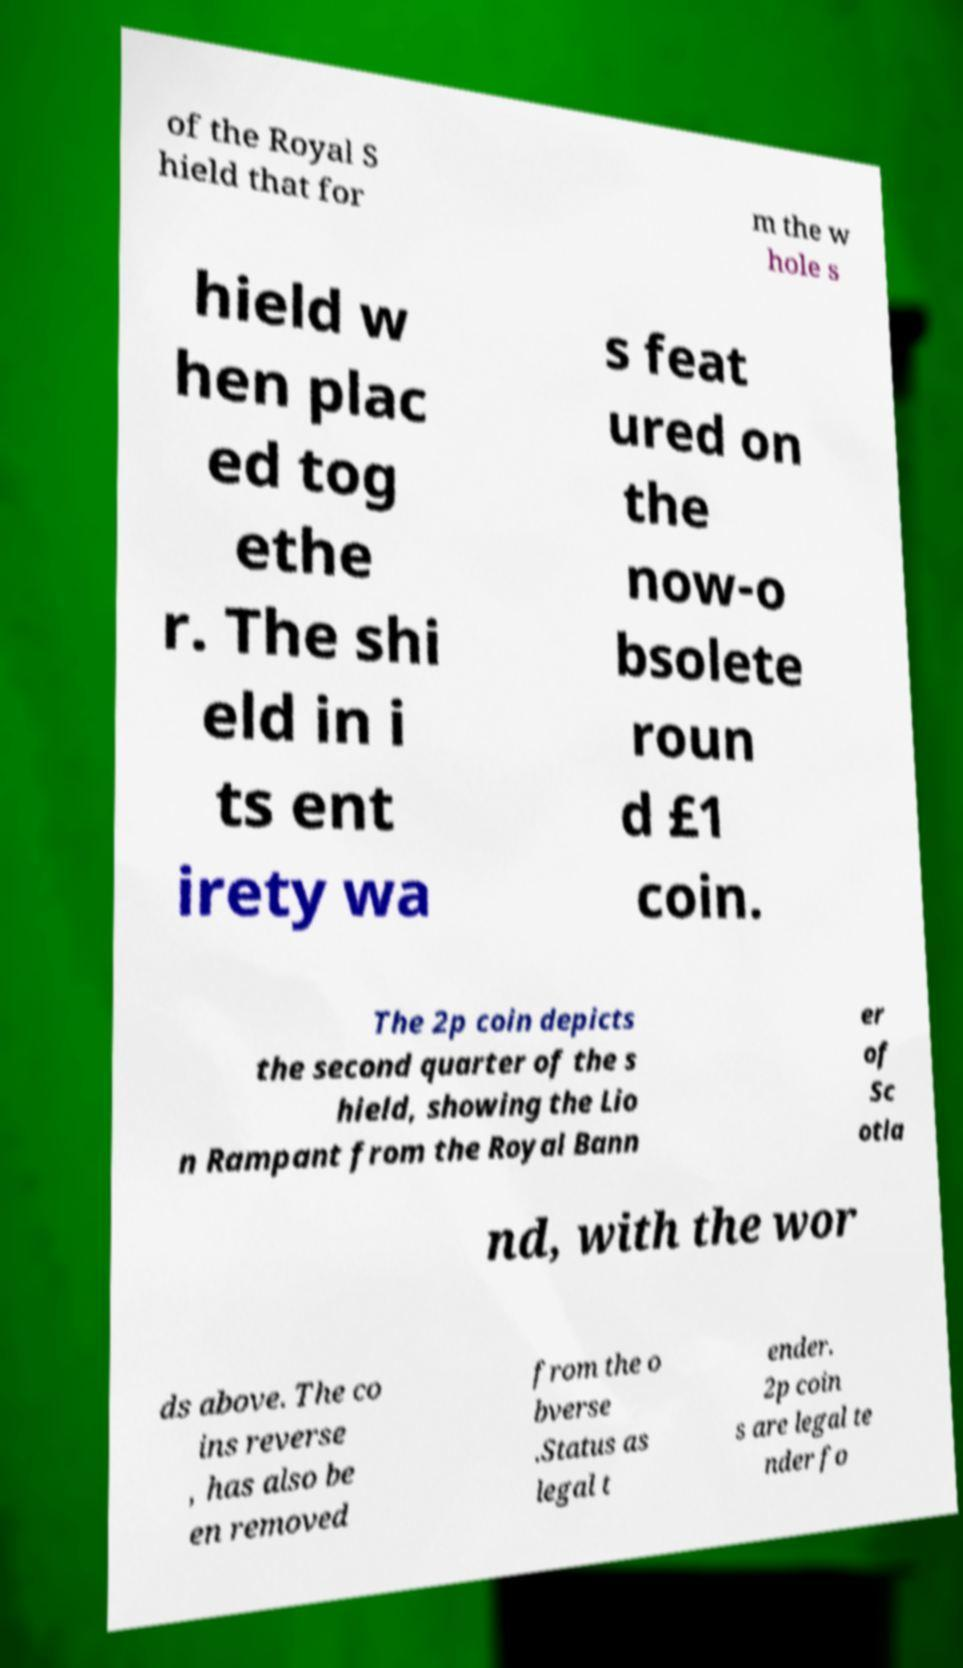Please identify and transcribe the text found in this image. of the Royal S hield that for m the w hole s hield w hen plac ed tog ethe r. The shi eld in i ts ent irety wa s feat ured on the now-o bsolete roun d £1 coin. The 2p coin depicts the second quarter of the s hield, showing the Lio n Rampant from the Royal Bann er of Sc otla nd, with the wor ds above. The co ins reverse , has also be en removed from the o bverse .Status as legal t ender. 2p coin s are legal te nder fo 